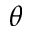<formula> <loc_0><loc_0><loc_500><loc_500>\theta</formula> 